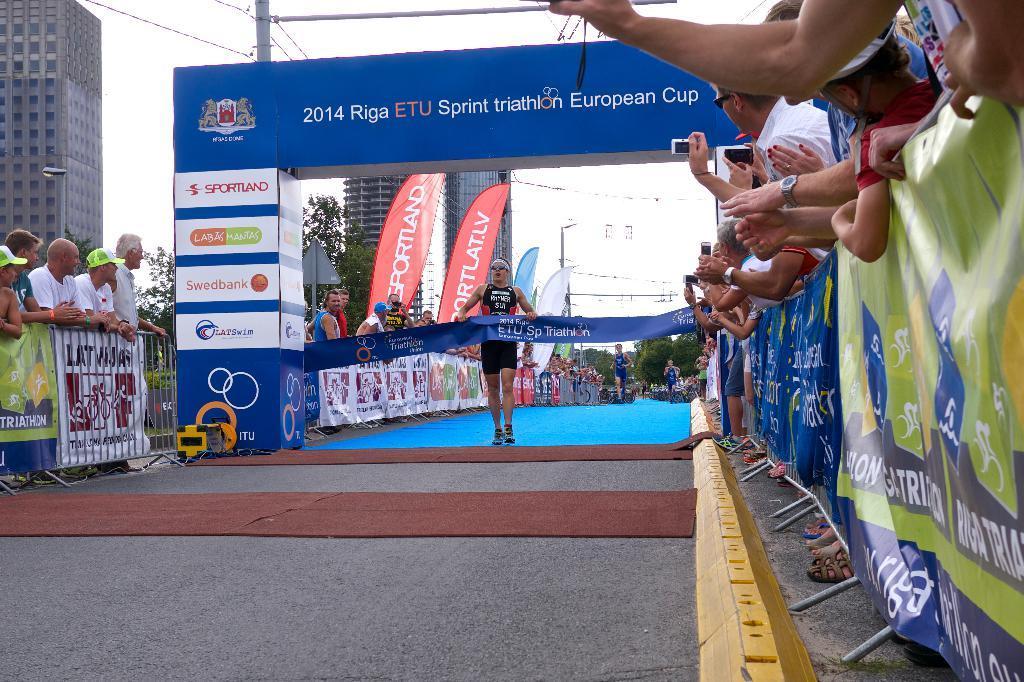Can you describe this image briefly? On the right side. There are many people. Some are holding mobile and camera. And there is a banner with stands. On the left side there is a railing. And there are many people. Also there is an arch. On that something is written. And there is a lady holding a banner. In the background there are many people, trees, buildings and sky. Also there is a pole. 